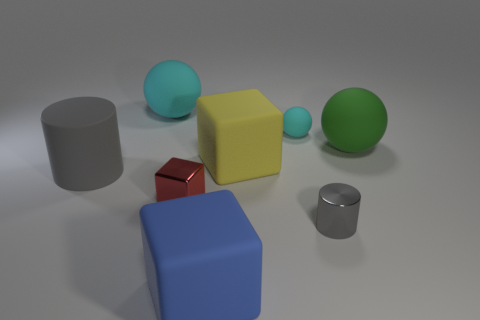What is the shape of the blue object?
Your answer should be very brief. Cube. What number of big blue matte objects are behind the small rubber ball?
Ensure brevity in your answer.  0. How many large green balls have the same material as the tiny cube?
Give a very brief answer. 0. Is the large block right of the blue matte block made of the same material as the big blue object?
Make the answer very short. Yes. Are there any tiny yellow shiny cubes?
Offer a terse response. No. There is a block that is right of the red thing and in front of the large gray rubber cylinder; how big is it?
Your answer should be very brief. Large. Are there more large cyan spheres that are in front of the red shiny block than cubes to the left of the yellow rubber object?
Your answer should be very brief. No. The ball that is the same color as the small rubber object is what size?
Provide a short and direct response. Large. What color is the tiny metallic cylinder?
Ensure brevity in your answer.  Gray. There is a small thing that is both on the right side of the large blue thing and in front of the tiny cyan sphere; what is its color?
Your answer should be very brief. Gray. 